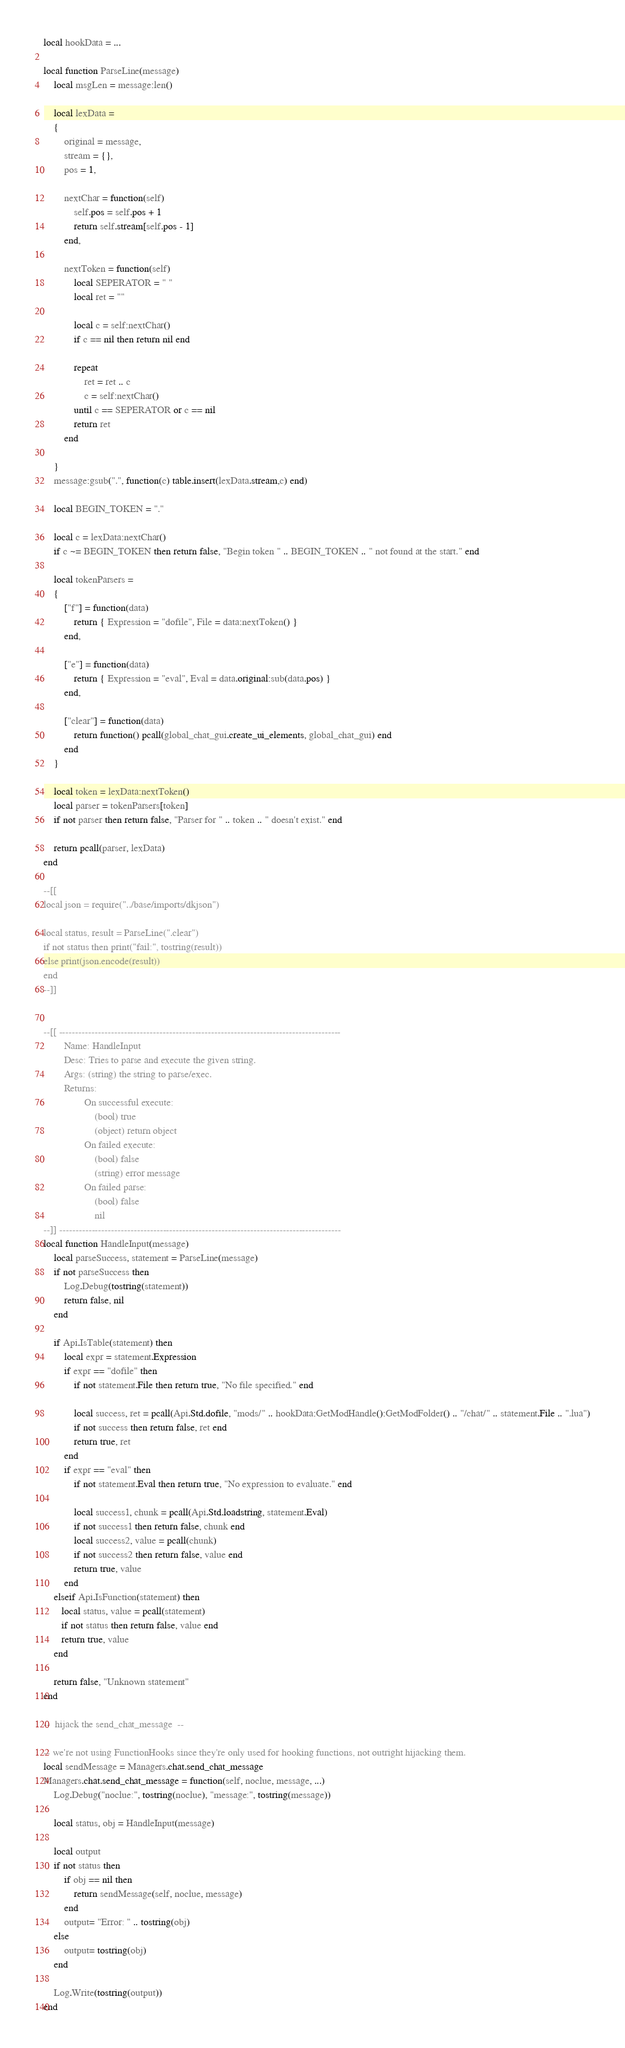<code> <loc_0><loc_0><loc_500><loc_500><_Lua_>local hookData = ...

local function ParseLine(message)
    local msgLen = message:len()
    
    local lexData = 
    {
        original = message,
        stream = {},
        pos = 1,
        
        nextChar = function(self)
            self.pos = self.pos + 1
            return self.stream[self.pos - 1]
        end,
        
        nextToken = function(self)
            local SEPERATOR = " "
            local ret = ""
            
            local c = self:nextChar()
            if c == nil then return nil end
                
            repeat
                ret = ret .. c
                c = self:nextChar()
            until c == SEPERATOR or c == nil
            return ret
        end
            
    }
    message:gsub(".", function(c) table.insert(lexData.stream,c) end)
    
    local BEGIN_TOKEN = "."
    
    local c = lexData:nextChar()
    if c ~= BEGIN_TOKEN then return false, "Begin token " .. BEGIN_TOKEN .. " not found at the start." end
    
    local tokenParsers = 
    {
        ["f"] = function(data)
            return { Expression = "dofile", File = data:nextToken() }
        end,
    
        ["e"] = function(data)
            return { Expression = "eval", Eval = data.original:sub(data.pos) }
        end,
        
        ["clear"] = function(data)
            return function() pcall(global_chat_gui.create_ui_elements, global_chat_gui) end
        end
    }
    
    local token = lexData:nextToken()
    local parser = tokenParsers[token]
    if not parser then return false, "Parser for " .. token .. " doesn't exist." end
        
    return pcall(parser, lexData)
end

--[[
local json = require("../base/imports/dkjson")

local status, result = ParseLine(".clear")
if not status then print("fail:", tostring(result))
else print(json.encode(result))
end
--]]


--[[ ---------------------------------------------------------------------------------------
        Name: HandleInput
        Desc: Tries to parse and execute the given string.
        Args: (string) the string to parse/exec.
        Returns: 
                On successful execute:
                    (bool) true
                    (object) return object
                On failed execute:
                    (bool) false
                    (string) error message
                On failed parse:
                    (bool) false
                    nil
--]] ---------------------------------------------------------------------------------------
local function HandleInput(message)
    local parseSuccess, statement = ParseLine(message)
    if not parseSuccess then 
        Log.Debug(tostring(statement))
        return false, nil 
    end
    
    if Api.IsTable(statement) then 
        local expr = statement.Expression
        if expr == "dofile" then
            if not statement.File then return true, "No file specified." end
            
            local success, ret = pcall(Api.Std.dofile, "mods/" .. hookData:GetModHandle():GetModFolder() .. "/chat/" .. statement.File .. ".lua")
            if not success then return false, ret end
            return true, ret
        end
        if expr == "eval" then
            if not statement.Eval then return true, "No expression to evaluate." end

            local success1, chunk = pcall(Api.Std.loadstring, statement.Eval)
            if not success1 then return false, chunk end
            local success2, value = pcall(chunk)
            if not success2 then return false, value end
            return true, value
        end
    elseif Api.IsFunction(statement) then
       local status, value = pcall(statement)
       if not status then return false, value end
       return true, value
    end
    
    return false, "Unknown statement"
end

--  hijack the send_chat_message  --

-- we're not using FunctionHooks since they're only used for hooking functions, not outright hijacking them.
local sendMessage = Managers.chat.send_chat_message
Managers.chat.send_chat_message = function(self, noclue, message, ...)
    Log.Debug("noclue:", tostring(noclue), "message:", tostring(message))
    
    local status, obj = HandleInput(message)
    
    local output
    if not status then
        if obj == nil then
            return sendMessage(self, noclue, message)
        end
        output= "Error: " .. tostring(obj)
    else
        output= tostring(obj)
    end
    
    Log.Write(tostring(output))
end
</code> 